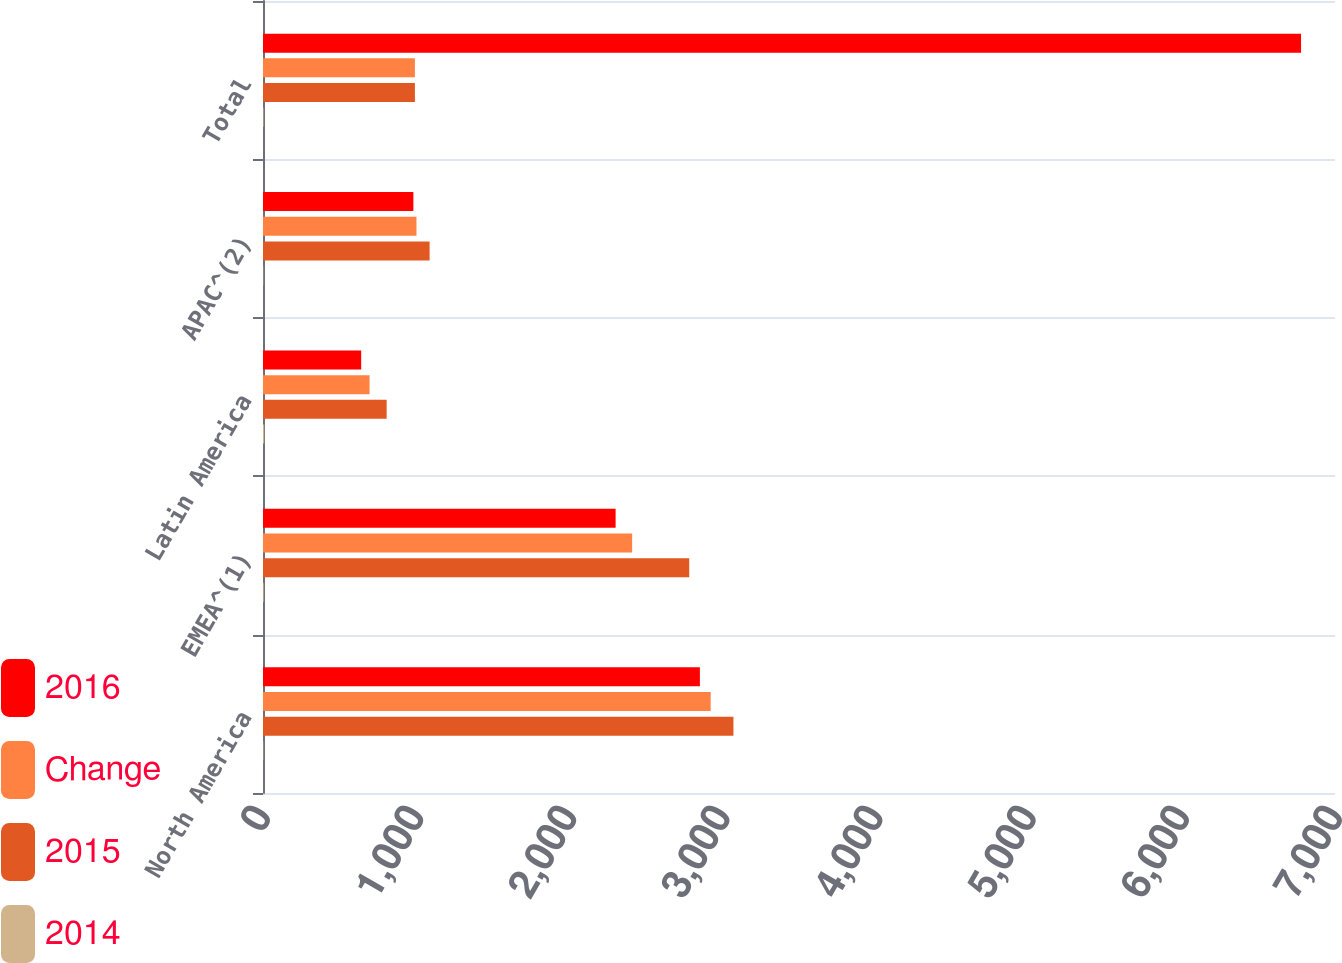Convert chart. <chart><loc_0><loc_0><loc_500><loc_500><stacked_bar_chart><ecel><fcel>North America<fcel>EMEA^(1)<fcel>Latin America<fcel>APAC^(2)<fcel>Total<nl><fcel>2016<fcel>2852.8<fcel>2302.5<fcel>641.1<fcel>981.9<fcel>6778.3<nl><fcel>Change<fcel>2923.2<fcel>2410.4<fcel>695.8<fcel>1002.1<fcel>992<nl><fcel>2015<fcel>3071.9<fcel>2783.2<fcel>807.5<fcel>1087.9<fcel>992<nl><fcel>2014<fcel>2.4<fcel>4.5<fcel>7.9<fcel>2<fcel>3.6<nl></chart> 